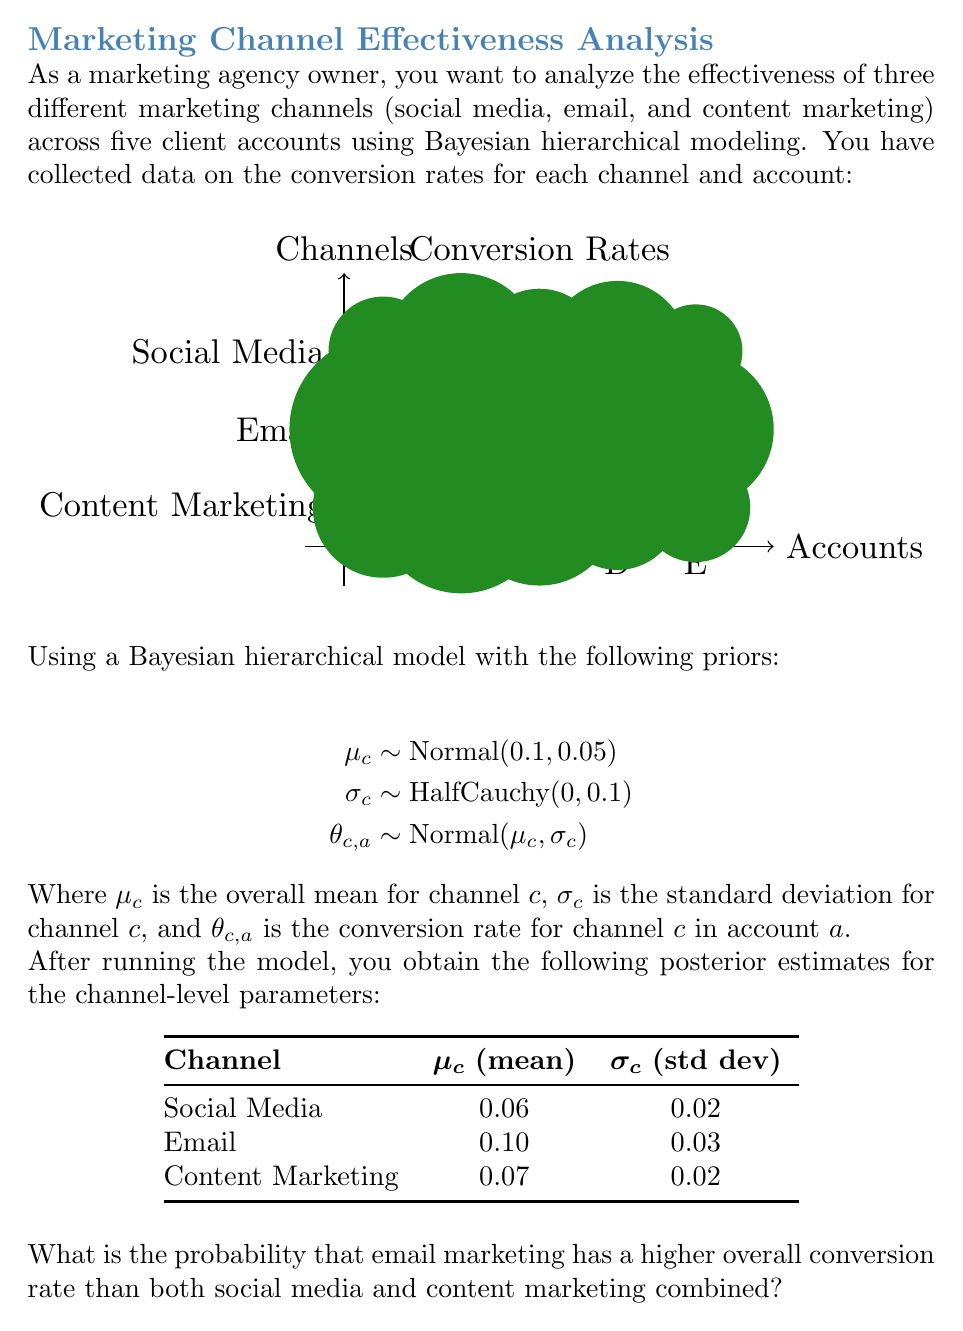Provide a solution to this math problem. To solve this problem, we need to use the posterior distributions of the channel-level means ($\mu_c$) to calculate the probability that email marketing outperforms the combined effect of social media and content marketing. We'll follow these steps:

1. Define the random variables:
   Let $E$, $S$, and $C$ represent the overall conversion rates for email, social media, and content marketing, respectively.

2. Use the posterior estimates:
   $E \sim \text{Normal}(0.10, 0.03)$
   $S \sim \text{Normal}(0.06, 0.02)$
   $C \sim \text{Normal}(0.07, 0.02)$

3. Define the condition we want to calculate:
   We need to find $P(E > S + C)$

4. Since $S$ and $C$ are independent, we can combine them:
   $S + C \sim \text{Normal}(0.06 + 0.07, \sqrt{0.02^2 + 0.02^2})$
   $S + C \sim \text{Normal}(0.13, \sqrt{0.0008})$
   $S + C \sim \text{Normal}(0.13, 0.0283)$

5. Now we have:
   $E \sim \text{Normal}(0.10, 0.03)$
   $S + C \sim \text{Normal}(0.13, 0.0283)$

6. To find $P(E > S + C)$, we need to calculate $P(E - (S + C) > 0)$

7. The difference of two normal distributions is also normal:
   $E - (S + C) \sim \text{Normal}(0.10 - 0.13, \sqrt{0.03^2 + 0.0283^2})$
   $E - (S + C) \sim \text{Normal}(-0.03, 0.0412)$

8. We want to find $P(X > 0)$ where $X \sim \text{Normal}(-0.03, 0.0412)$

9. Standardize the normal distribution:
   $Z = \frac{X - \mu}{\sigma} = \frac{0 - (-0.03)}{0.0412} = 0.7282$

10. Use the standard normal table or a calculator to find $P(Z > 0.7282)$:
    $P(Z > 0.7282) = 1 - \Phi(0.7282) \approx 0.2332$

Therefore, the probability that email marketing has a higher overall conversion rate than both social media and content marketing combined is approximately 0.2332 or 23.32%.
Answer: 0.2332 